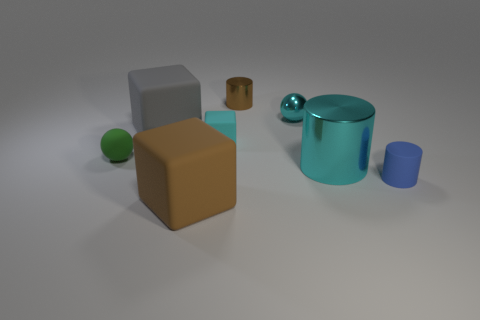There is another tiny object that is the same shape as the brown shiny thing; what is it made of?
Ensure brevity in your answer.  Rubber. There is a small cube that is the same color as the big metal thing; what is its material?
Provide a short and direct response. Rubber. What is the material of the cyan ball that is the same size as the brown shiny thing?
Give a very brief answer. Metal. What shape is the object that is to the right of the cyan object that is to the right of the sphere to the right of the small brown thing?
Your answer should be compact. Cylinder. What shape is the brown object that is the same size as the gray cube?
Your answer should be very brief. Cube. How many small objects are behind the large matte cube behind the ball on the left side of the cyan matte thing?
Keep it short and to the point. 2. Is the number of large matte things that are in front of the cyan cylinder greater than the number of small objects that are to the left of the small brown thing?
Offer a very short reply. No. How many brown objects have the same shape as the small blue thing?
Offer a very short reply. 1. How many things are cyan things on the right side of the small brown cylinder or rubber objects behind the big brown thing?
Make the answer very short. 6. What is the material of the tiny cyan ball in front of the metallic cylinder behind the small ball that is to the left of the gray block?
Your answer should be compact. Metal. 